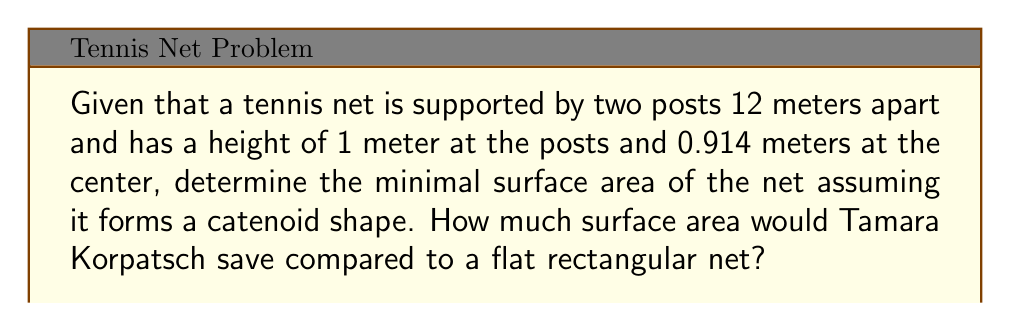Help me with this question. To solve this problem, we'll follow these steps:

1) The catenoid is a minimal surface formed by rotating a catenary curve around an axis. The equation of a catenary is:

   $$y = a \cosh(\frac{x}{a})$$

   where $a$ is a constant we need to determine.

2) We know the boundary conditions:
   At $x = \pm 6$ m, $y = 1$ m
   At $x = 0$ m, $y = 0.914$ m

3) Using the first condition:

   $$1 = a \cosh(\frac{6}{a})$$

4) Using the second condition:

   $$0.914 = a \cosh(0) = a$$

5) Substituting this back into the first equation:

   $$1 = 0.914 \cosh(\frac{6}{0.914})$$

   This equation is satisfied, confirming our solution.

6) The surface area of a catenoid is given by:

   $$S = 2\pi a^2 \sinh(\frac{b}{a})$$

   where $b$ is half the distance between the posts.

7) Substituting our values:

   $$S = 2\pi (0.914)^2 \sinh(\frac{6}{0.914}) = 34.62 \text{ m}^2$$

8) The area of a flat rectangular net would be:

   $$A = 12 \times 1 = 12 \text{ m}^2$$

9) The difference in surface area is:

   $$34.62 - 12 = 22.62 \text{ m}^2$$

Therefore, Tamara Korpatsch would save 22.62 square meters of net material by using a catenoid shape instead of a flat rectangle.
Answer: 22.62 m² 